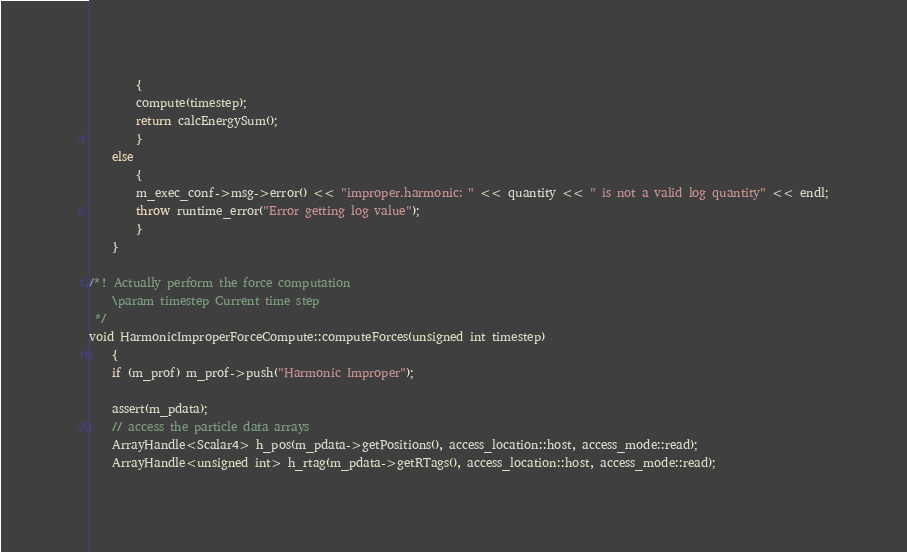Convert code to text. <code><loc_0><loc_0><loc_500><loc_500><_C++_>        {
        compute(timestep);
        return calcEnergySum();
        }
    else
        {
        m_exec_conf->msg->error() << "improper.harmonic: " << quantity << " is not a valid log quantity" << endl;
        throw runtime_error("Error getting log value");
        }
    }

/*! Actually perform the force computation
    \param timestep Current time step
 */
void HarmonicImproperForceCompute::computeForces(unsigned int timestep)
    {
    if (m_prof) m_prof->push("Harmonic Improper");

    assert(m_pdata);
    // access the particle data arrays
    ArrayHandle<Scalar4> h_pos(m_pdata->getPositions(), access_location::host, access_mode::read);
    ArrayHandle<unsigned int> h_rtag(m_pdata->getRTags(), access_location::host, access_mode::read);
</code> 